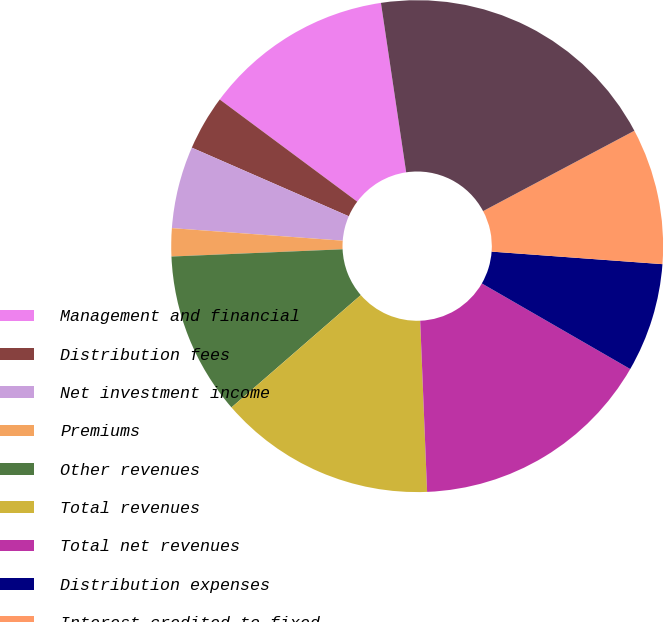Convert chart to OTSL. <chart><loc_0><loc_0><loc_500><loc_500><pie_chart><fcel>Management and financial<fcel>Distribution fees<fcel>Net investment income<fcel>Premiums<fcel>Other revenues<fcel>Total revenues<fcel>Total net revenues<fcel>Distribution expenses<fcel>Interest credited to fixed<fcel>Benefits claims losses and<nl><fcel>12.48%<fcel>3.61%<fcel>5.39%<fcel>1.84%<fcel>10.71%<fcel>14.26%<fcel>16.03%<fcel>7.16%<fcel>8.94%<fcel>19.58%<nl></chart> 